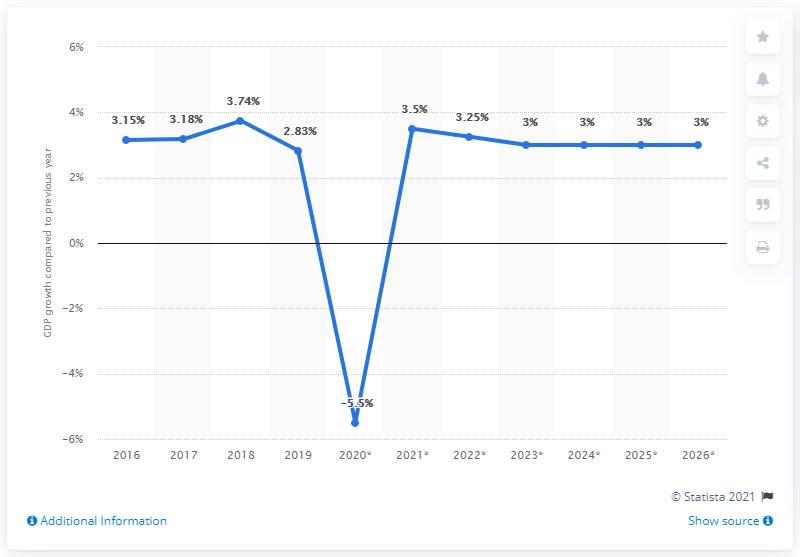Point out several critical features in this image. The average percentage value between the first and last data point in the chart is 3.07%. In 2020, the value was below 0. 